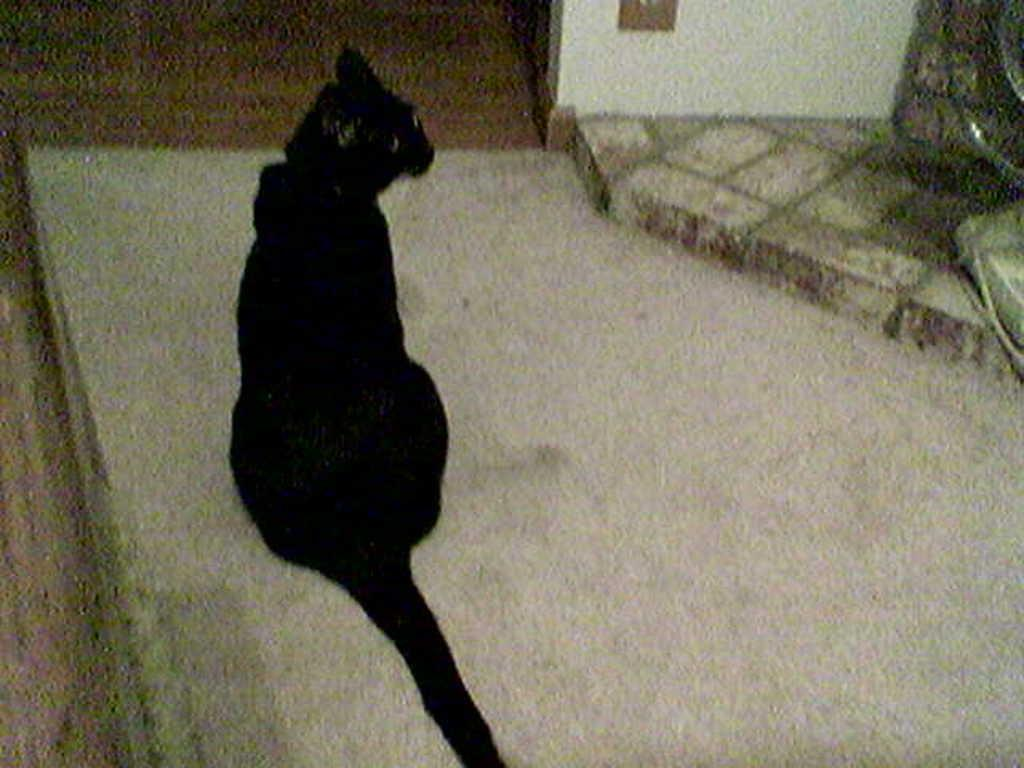What type of animal is in the image? There is a black color cat in the image. Where is the cat located in the image? The cat is sitting on the floor. What can be seen on the right side of the image? There is a wall on the right side of the image. How does the wind affect the cat's behavior in the image? There is no wind present in the image, so its behavior is not affected by any wind. 